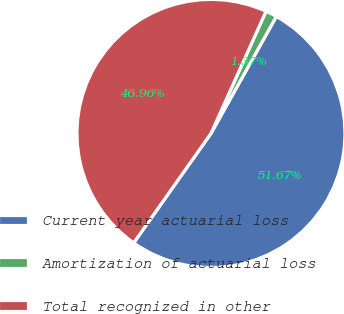<chart> <loc_0><loc_0><loc_500><loc_500><pie_chart><fcel>Current year actuarial loss<fcel>Amortization of actuarial loss<fcel>Total recognized in other<nl><fcel>51.67%<fcel>1.37%<fcel>46.96%<nl></chart> 